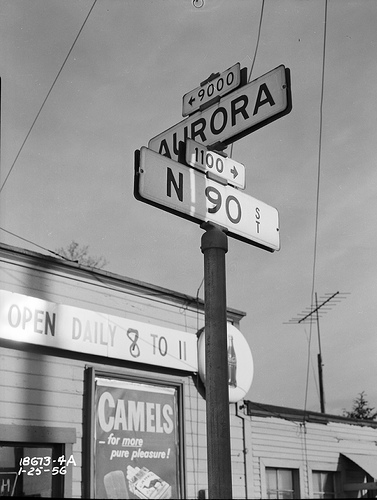Read all the text in this image. 9000 1100 N 90 CAMELS H 56 25 1 4A 8673 pleasure Pure more for II TO 8 DAILY OPEN ST 1100 